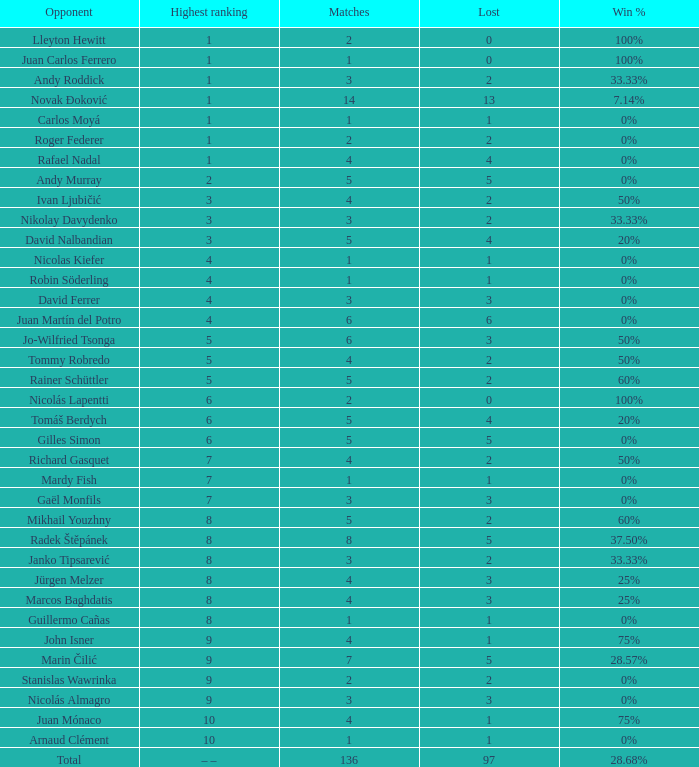What is the smallest number of Matches with less than 97 losses and a Win rate of 28.68%? None. 